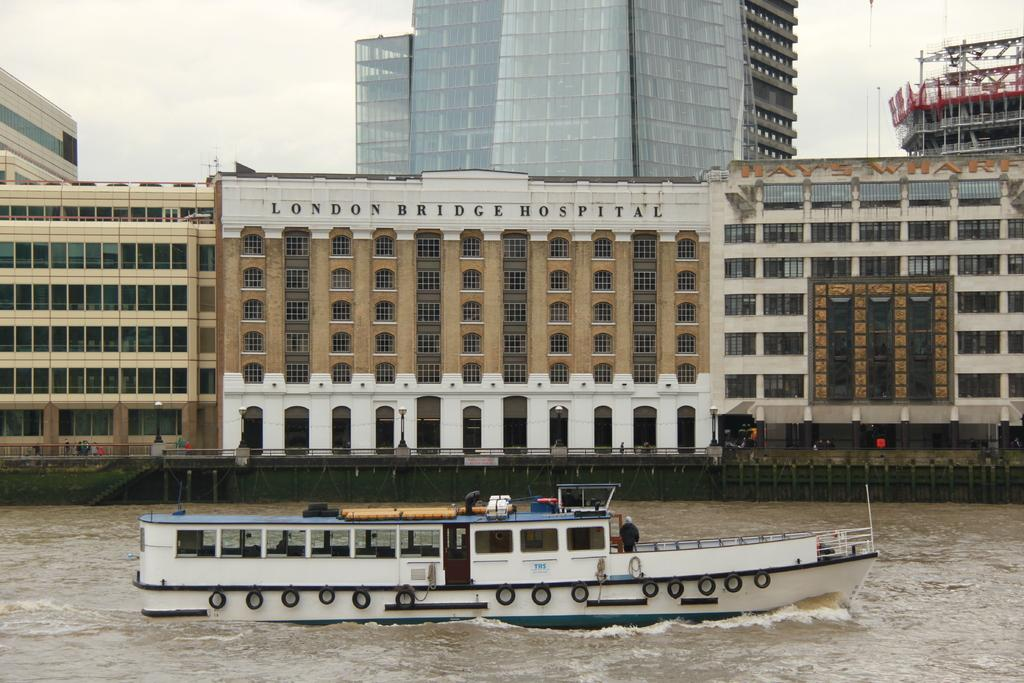<image>
Offer a succinct explanation of the picture presented. Ship is in the water and a London bridge hospital is behind it 